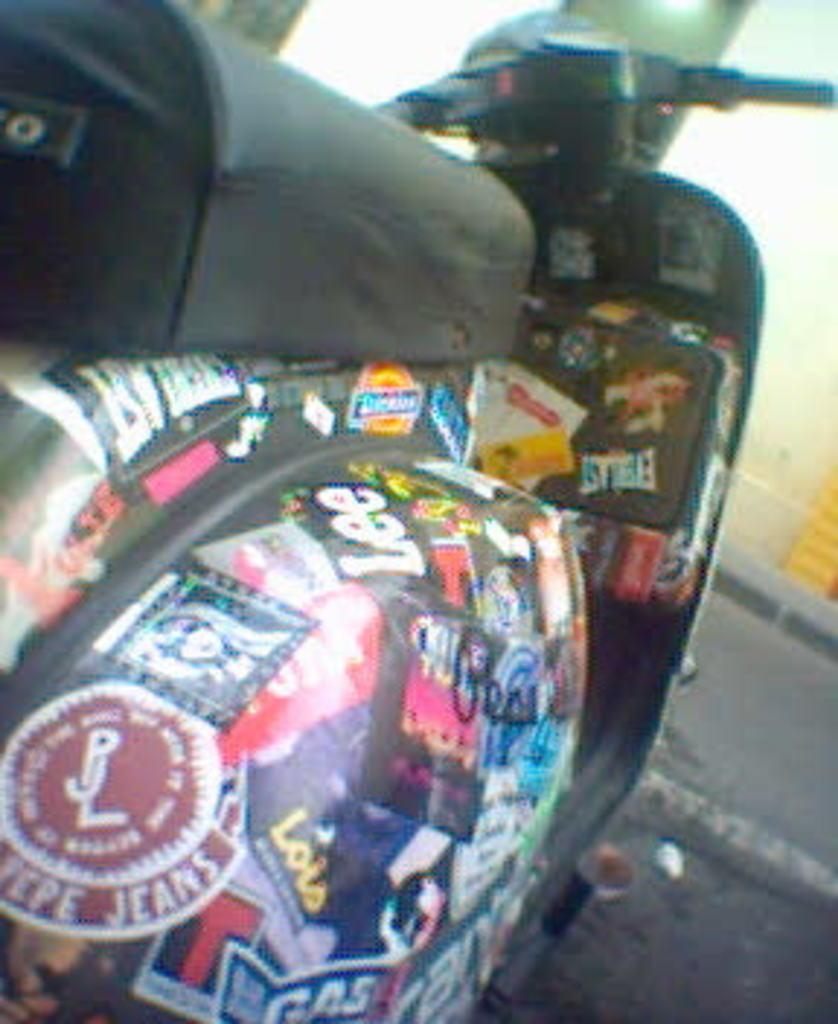What is the main object in the image? There is a scooter in the image. Are there any decorations or additions to the scooter? Yes, the scooter has posters pasted on it. What can be seen at the bottom of the image? There is a road visible at the bottom of the image. What is the color of the building in the background? The building in the background is white-colored. Reasoning: Let'g: Let's think step by step in order to produce the conversation. We start by identifying the main object in the image, which is the scooter. Then, we describe any additional features or decorations on the scooter, such as the posters. Next, we mention the road visible at the bottom of the image, which provides context for the scooter's location. Finally, we describe the background of the image, which includes a white-colored building. Absurd Question/Answer: Can you see any feathers on the scooter in the image? No, there are no feathers visible on the scooter in the image. Is there a person with a wound sitting on a chair in the image? No, there is no person with a wound or chair present in the image. 